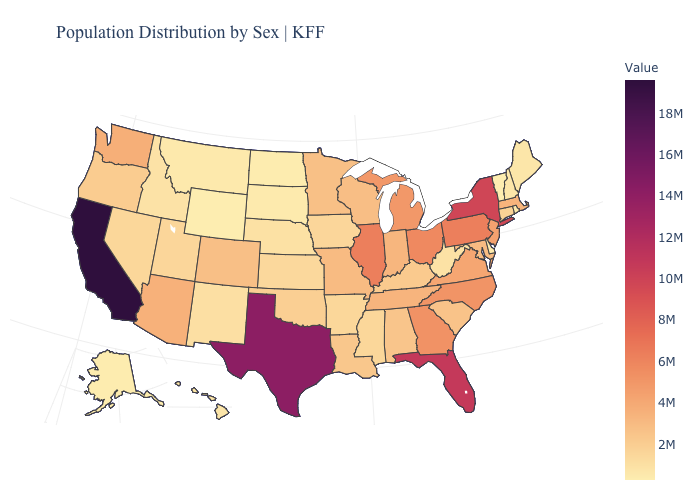Which states have the lowest value in the South?
Be succinct. Delaware. Does Delaware have the lowest value in the South?
Answer briefly. Yes. Does Michigan have a higher value than Oregon?
Be succinct. Yes. Which states hav the highest value in the West?
Write a very short answer. California. Which states hav the highest value in the South?
Answer briefly. Texas. Does Rhode Island have a lower value than North Carolina?
Write a very short answer. Yes. Does Oregon have the highest value in the West?
Answer briefly. No. 